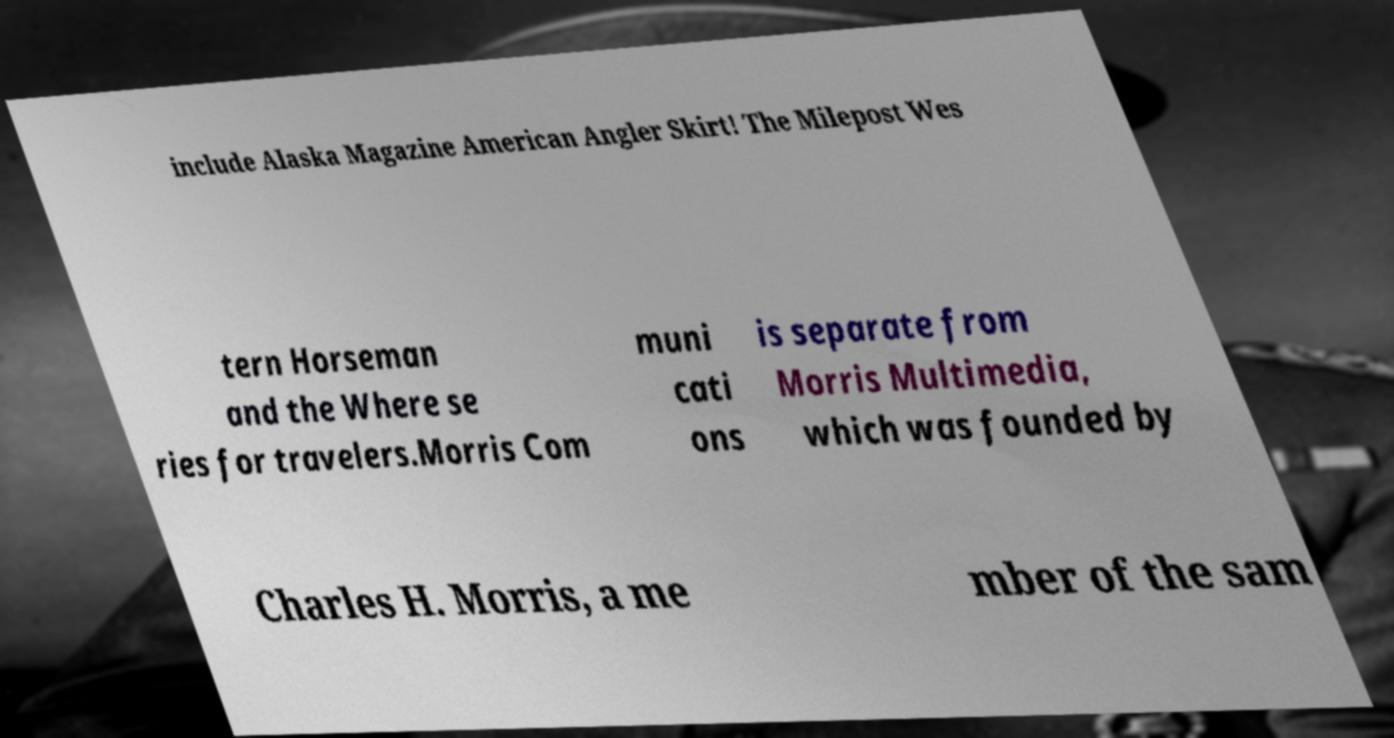Please read and relay the text visible in this image. What does it say? include Alaska Magazine American Angler Skirt! The Milepost Wes tern Horseman and the Where se ries for travelers.Morris Com muni cati ons is separate from Morris Multimedia, which was founded by Charles H. Morris, a me mber of the sam 